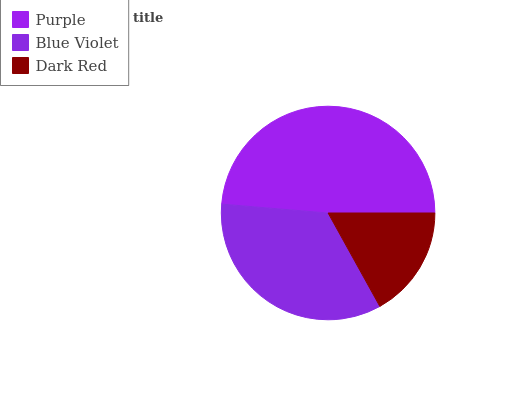Is Dark Red the minimum?
Answer yes or no. Yes. Is Purple the maximum?
Answer yes or no. Yes. Is Blue Violet the minimum?
Answer yes or no. No. Is Blue Violet the maximum?
Answer yes or no. No. Is Purple greater than Blue Violet?
Answer yes or no. Yes. Is Blue Violet less than Purple?
Answer yes or no. Yes. Is Blue Violet greater than Purple?
Answer yes or no. No. Is Purple less than Blue Violet?
Answer yes or no. No. Is Blue Violet the high median?
Answer yes or no. Yes. Is Blue Violet the low median?
Answer yes or no. Yes. Is Purple the high median?
Answer yes or no. No. Is Purple the low median?
Answer yes or no. No. 